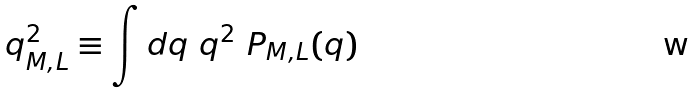Convert formula to latex. <formula><loc_0><loc_0><loc_500><loc_500>q ^ { 2 } _ { M , L } \equiv \int d q \ q ^ { 2 } \ P _ { M , L } ( q )</formula> 